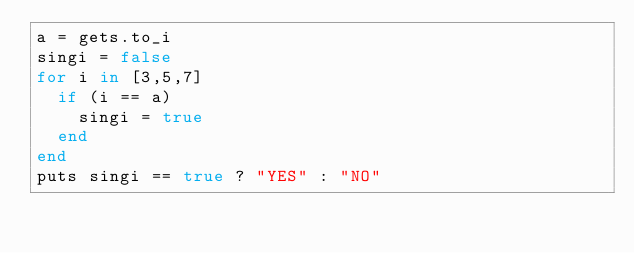Convert code to text. <code><loc_0><loc_0><loc_500><loc_500><_Ruby_>a = gets.to_i
singi = false
for i in [3,5,7]
  if (i == a)
    singi = true
  end
end
puts singi == true ? "YES" : "NO"
</code> 